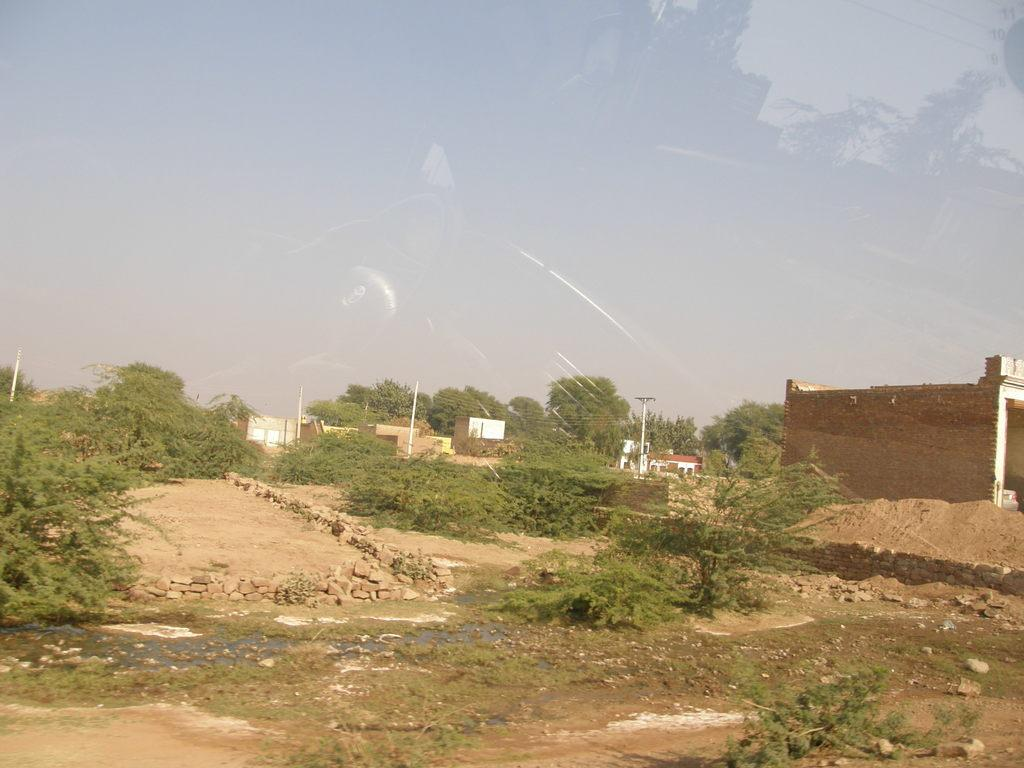Where was the image taken? The image was clicked outside the city. What can be seen in the foreground of the image? There is grass, plants, and stones in the foreground of the image. What is visible in the background of the image? There is a sky, buildings, trees, and a pole visible in the background of the image. How many horses are pulling the van in the image? There are no horses or van present in the image. What is the increase in the number of trees in the image? There is no indication of an increase or decrease in the number of trees in the image; the number of trees remains constant. 